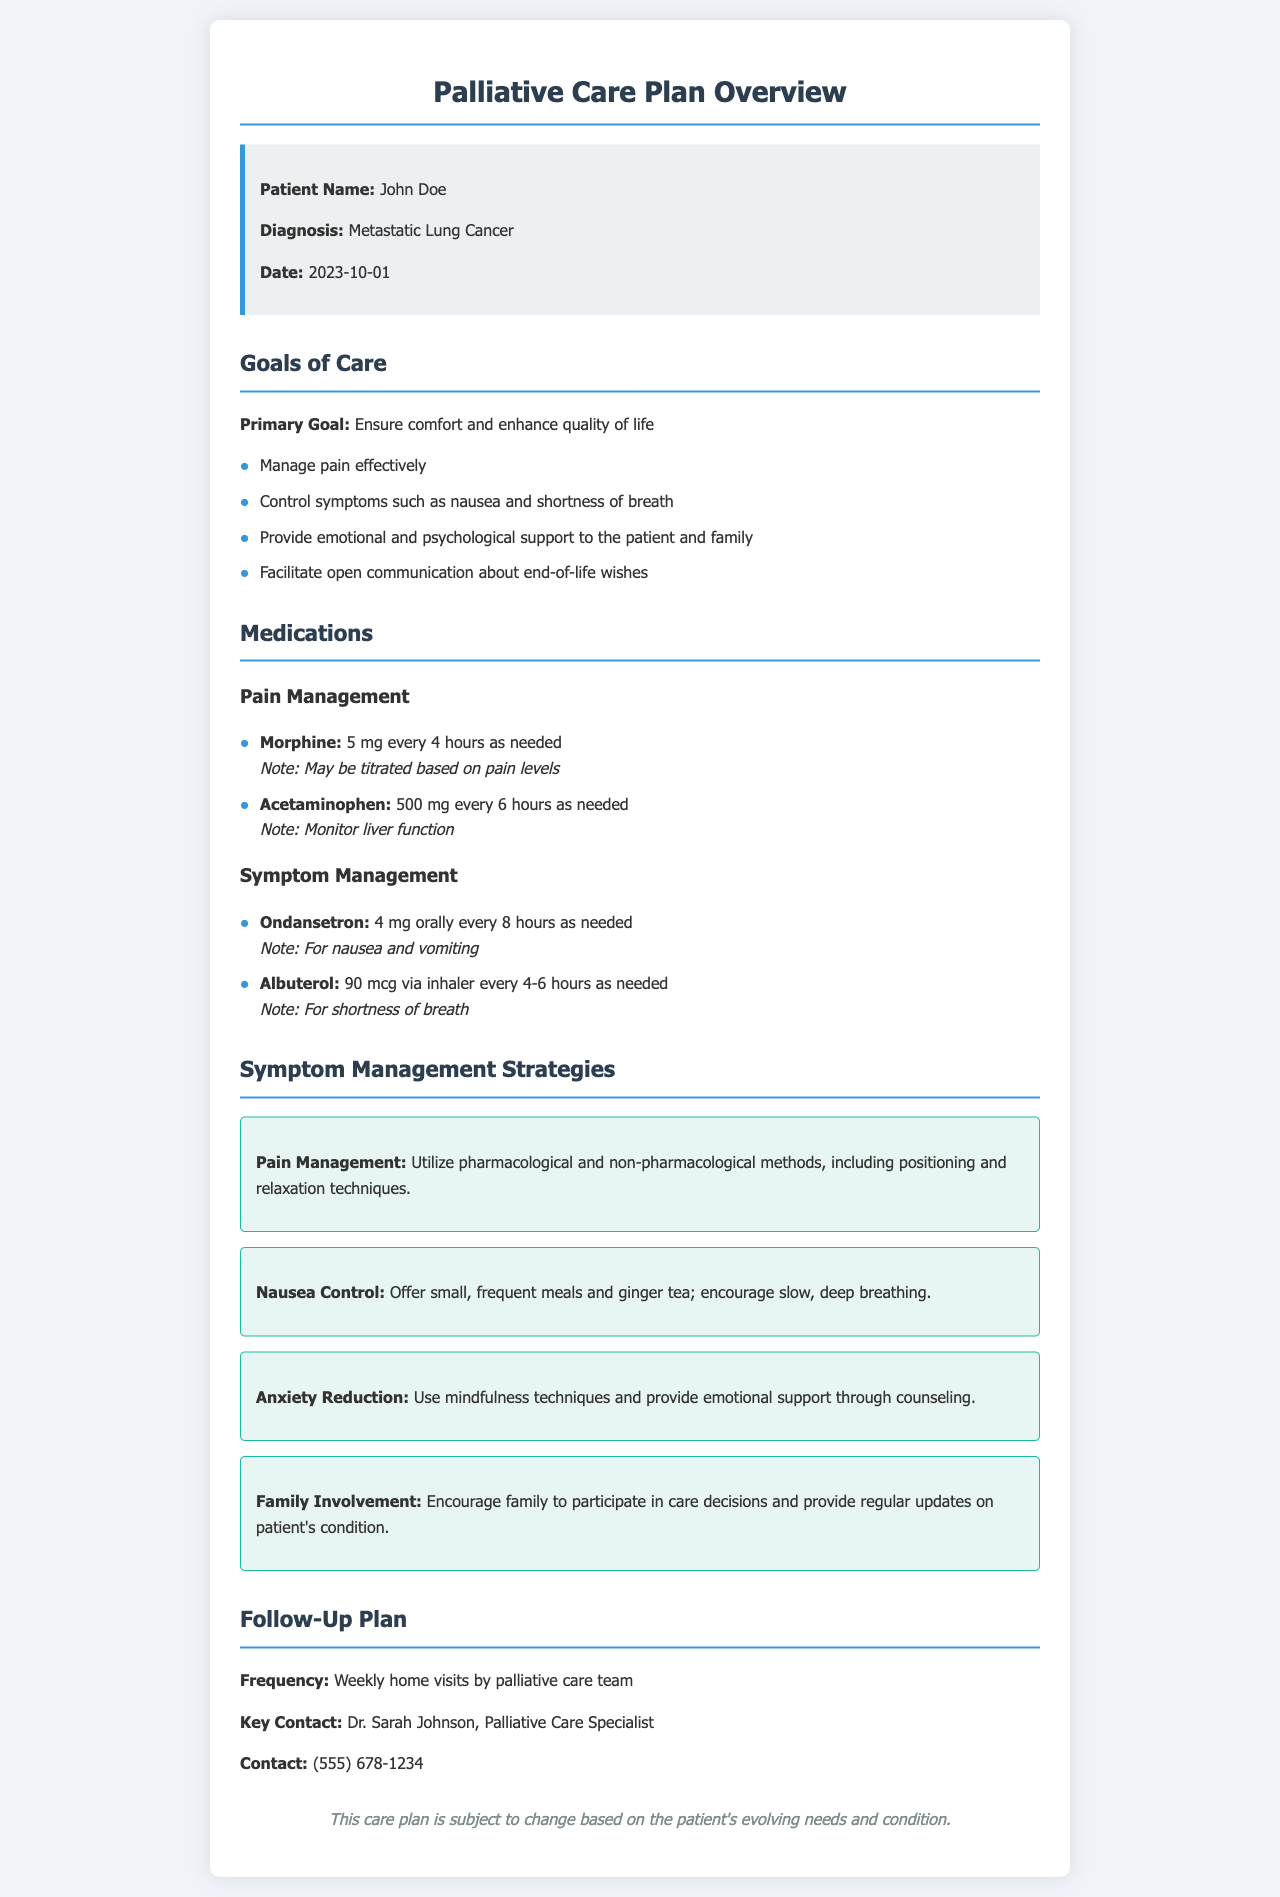What is the patient's name? The patient's name is listed at the top of the document under the patient information section.
Answer: John Doe What is the primary goal of care? The primary goal is stated clearly in the goals of care section.
Answer: Ensure comfort and enhance quality of life What medications are used for pain management? The medications for pain management are listed under the medications section, specifically for pain management.
Answer: Morphine, Acetaminophen How often should morphine be administered? The frequency of morphine administration is indicated alongside the medication details.
Answer: Every 4 hours as needed What strategy is recommended for anxiety reduction? The specific strategies for anxiety reduction are provided under the symptom management strategies section.
Answer: Use mindfulness techniques and provide emotional support through counseling What is the key contact's name for the follow-up plan? The key contact's name is mentioned in the follow-up plan section of the document.
Answer: Dr. Sarah Johnson How frequently will the palliative care team make home visits? The frequency of home visits is specified in the follow-up plan section.
Answer: Weekly What is recommended for nausea control? The strategies for nausea control are outlined within the symptom management strategies section.
Answer: Offer small, frequent meals and ginger tea What should be monitored in patients taking acetaminophen? The specific monitoring needed for acetaminophen use is detailed alongside the medication description.
Answer: Liver function 